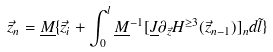Convert formula to latex. <formula><loc_0><loc_0><loc_500><loc_500>\vec { z } _ { n } = \underline { M } \{ \vec { z } _ { i } + \int _ { 0 } ^ { l } { \underline { M } } ^ { - 1 } [ \underline { J } \partial _ { \vec { z } } H ^ { \geq 3 } ( \vec { z } _ { n - 1 } ) ] _ { n } d \tilde { l } \}</formula> 